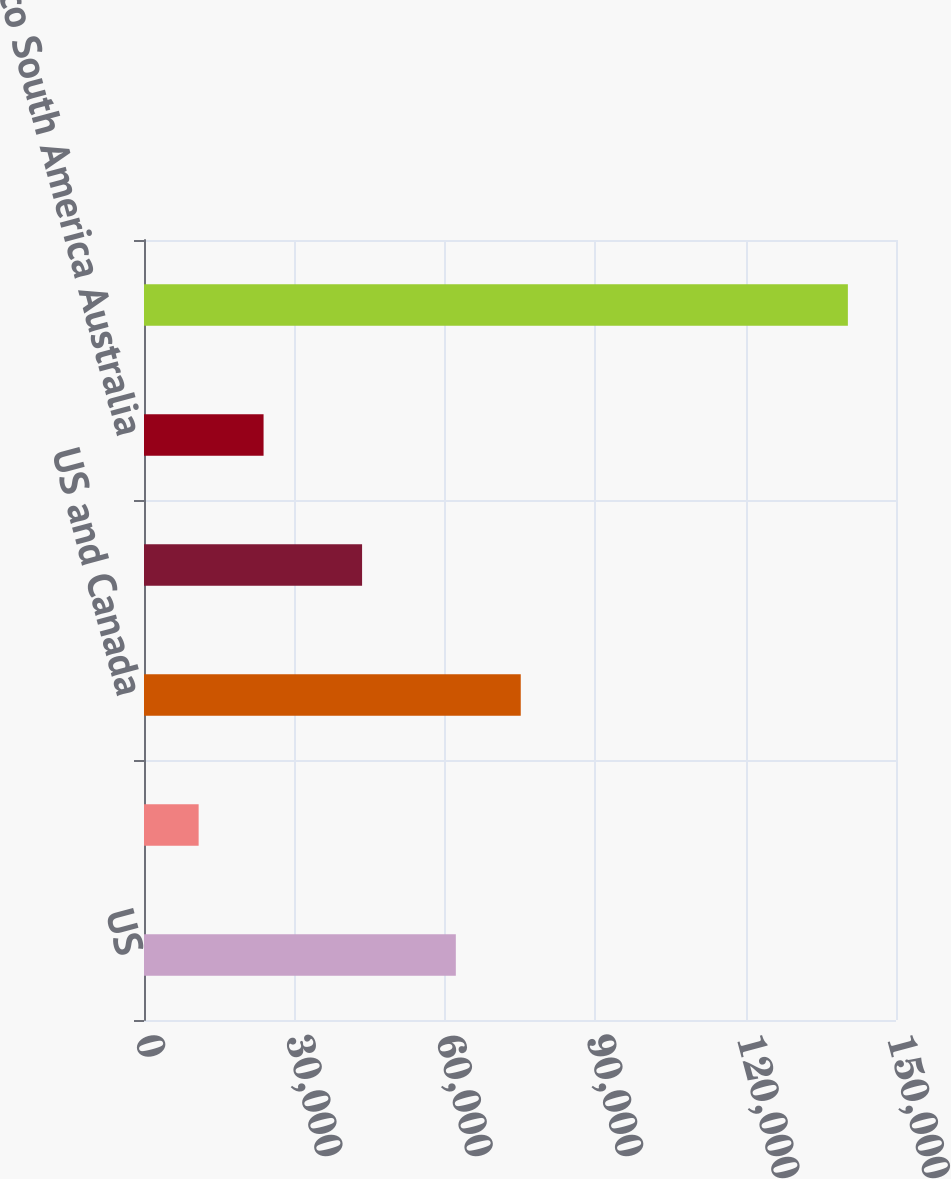Convert chart. <chart><loc_0><loc_0><loc_500><loc_500><bar_chart><fcel>US<fcel>Canada<fcel>US and Canada<fcel>Europe<fcel>Mexico South America Australia<fcel>Total units<nl><fcel>62200<fcel>10900<fcel>75150<fcel>43500<fcel>23850<fcel>140400<nl></chart> 